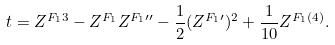Convert formula to latex. <formula><loc_0><loc_0><loc_500><loc_500>t = Z ^ { F _ { 1 } 3 } - Z ^ { F _ { 1 } } Z ^ { F _ { 1 } \prime \prime } - \frac { 1 } { 2 } ( Z ^ { F _ { 1 } \prime } ) ^ { 2 } + \frac { 1 } { 1 0 } Z ^ { F _ { 1 } ( 4 ) } .</formula> 